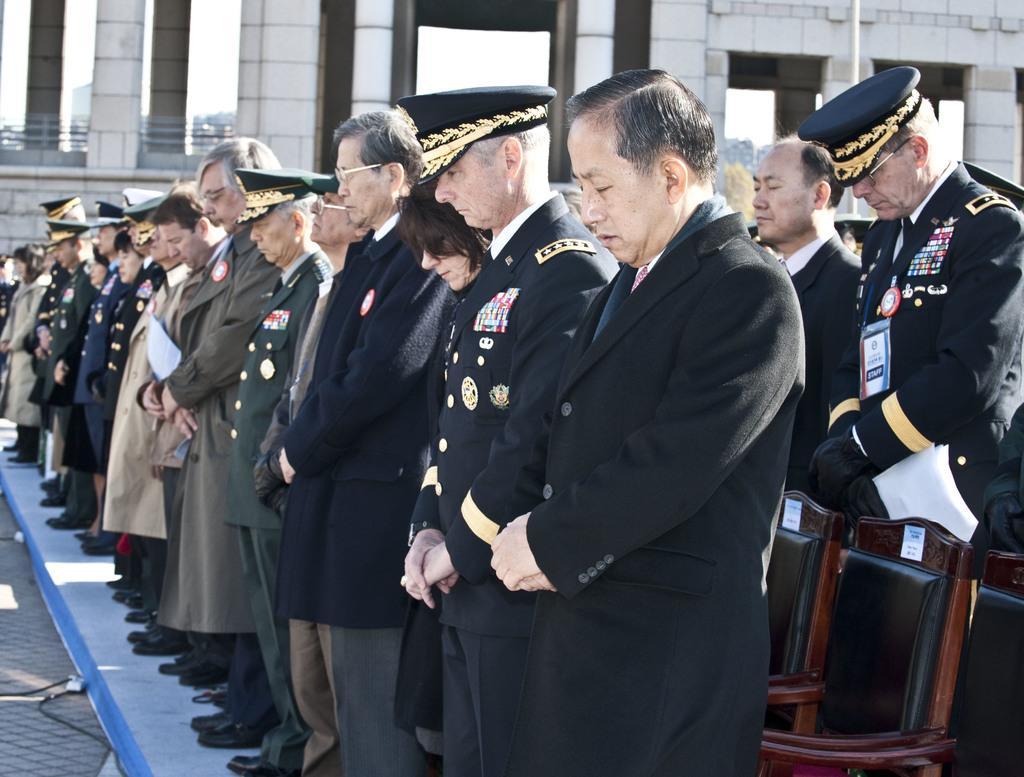Describe this image in one or two sentences. In this image, we can see people standing and are wearing uniforms and caps and there are chairs. In the background, there is a building. At the bottom, there is a road. 